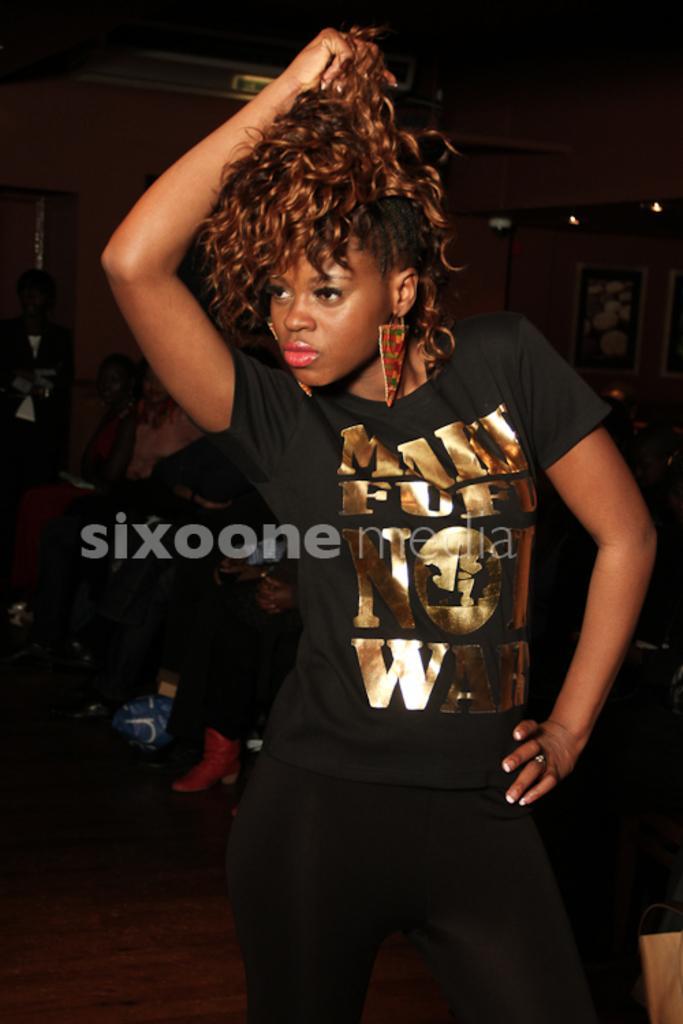How would you summarize this image in a sentence or two? In this image we can see a girl wearing black dress is standing on the floor. in the background, we can see group of people sitting, group of photo frames and some lights. 